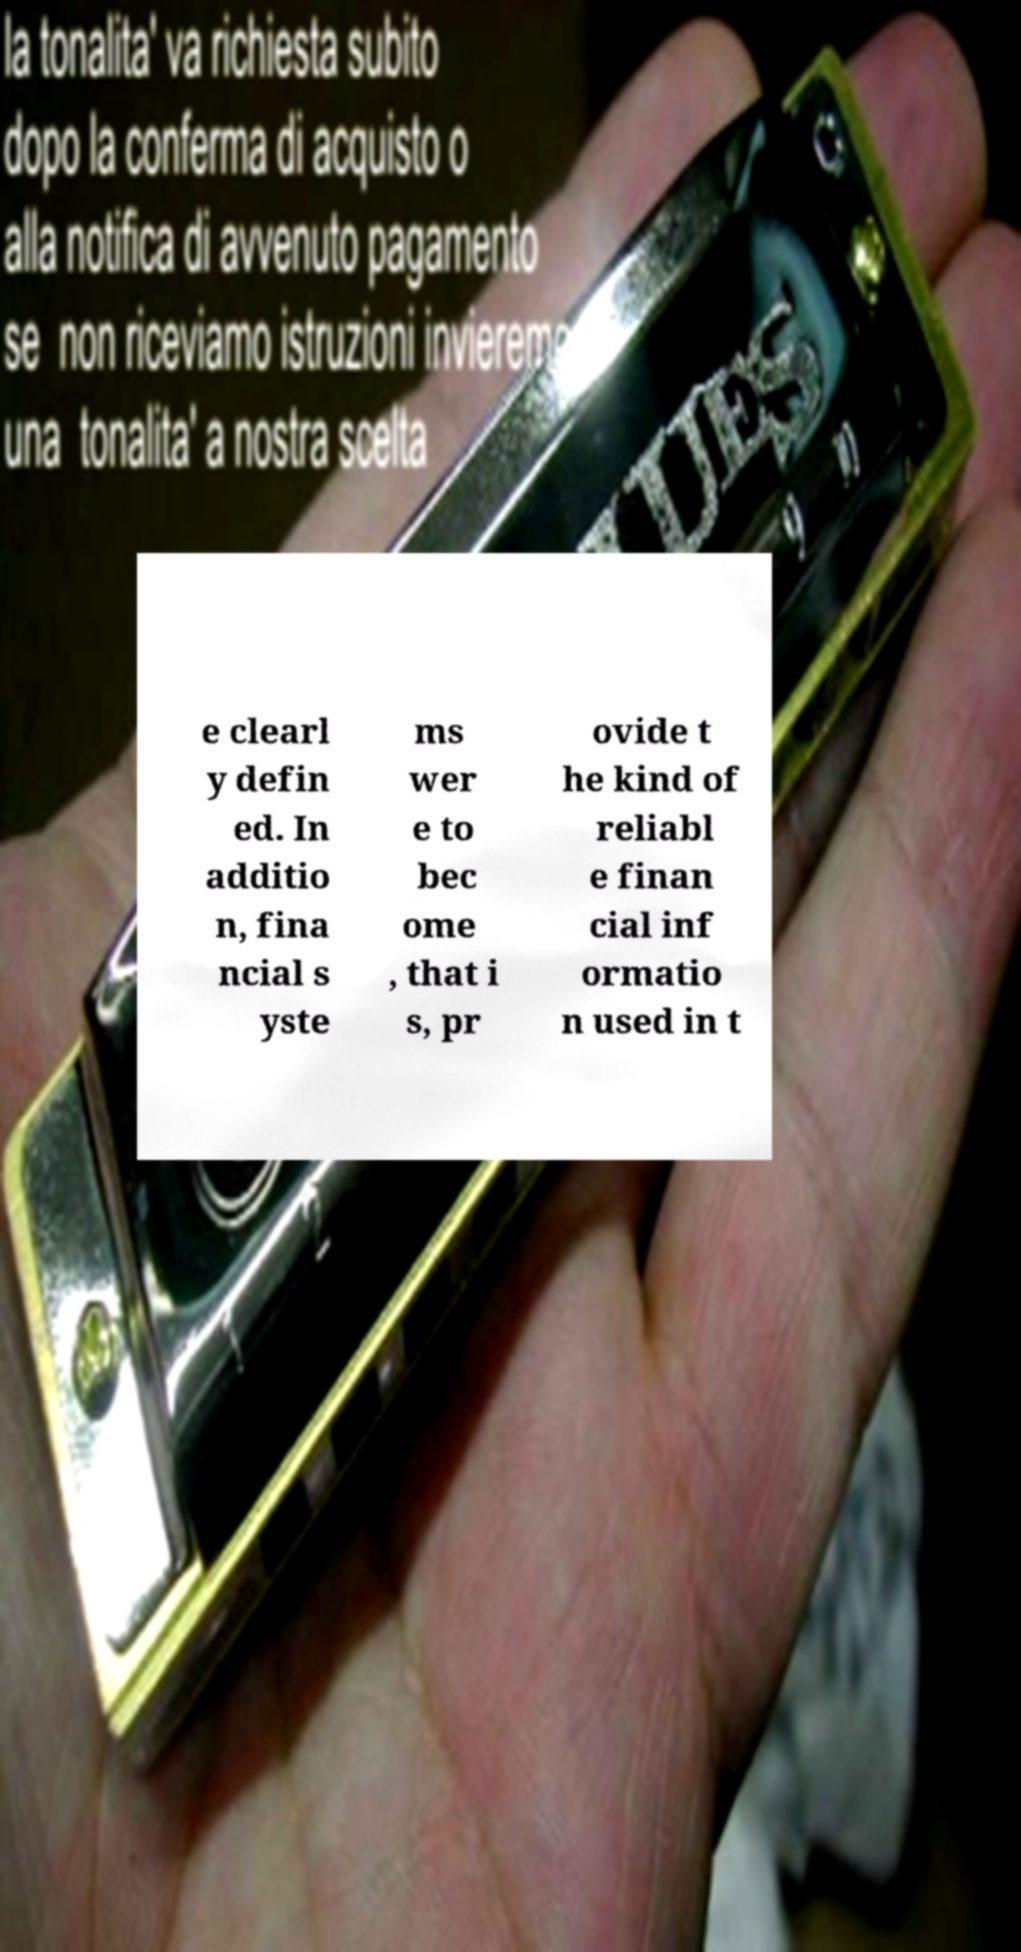Could you assist in decoding the text presented in this image and type it out clearly? e clearl y defin ed. In additio n, fina ncial s yste ms wer e to bec ome , that i s, pr ovide t he kind of reliabl e finan cial inf ormatio n used in t 